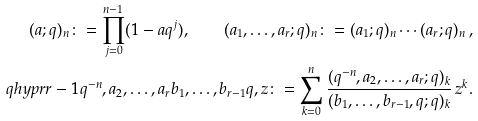<formula> <loc_0><loc_0><loc_500><loc_500>( a ; q ) _ { n } \colon = \prod _ { j = 0 } ^ { n - 1 } ( 1 - a q ^ { j } ) , \quad ( a _ { 1 } , \dots , a _ { r } ; q ) _ { n } \colon = ( a _ { 1 } ; q ) _ { n } \cdots ( a _ { r } ; q ) _ { n } \, , \\ \ q h y p r { r - 1 } { q ^ { - n } , a _ { 2 } , \dots , a _ { r } } { b _ { 1 } , \dots , b _ { r - 1 } } { q , z } \colon = \sum _ { k = 0 } ^ { n } \frac { ( q ^ { - n } , a _ { 2 } , \dots , a _ { r } ; q ) _ { k } } { ( b _ { 1 } , \dots , b _ { r - 1 } , q ; q ) _ { k } } \, z ^ { k } .</formula> 